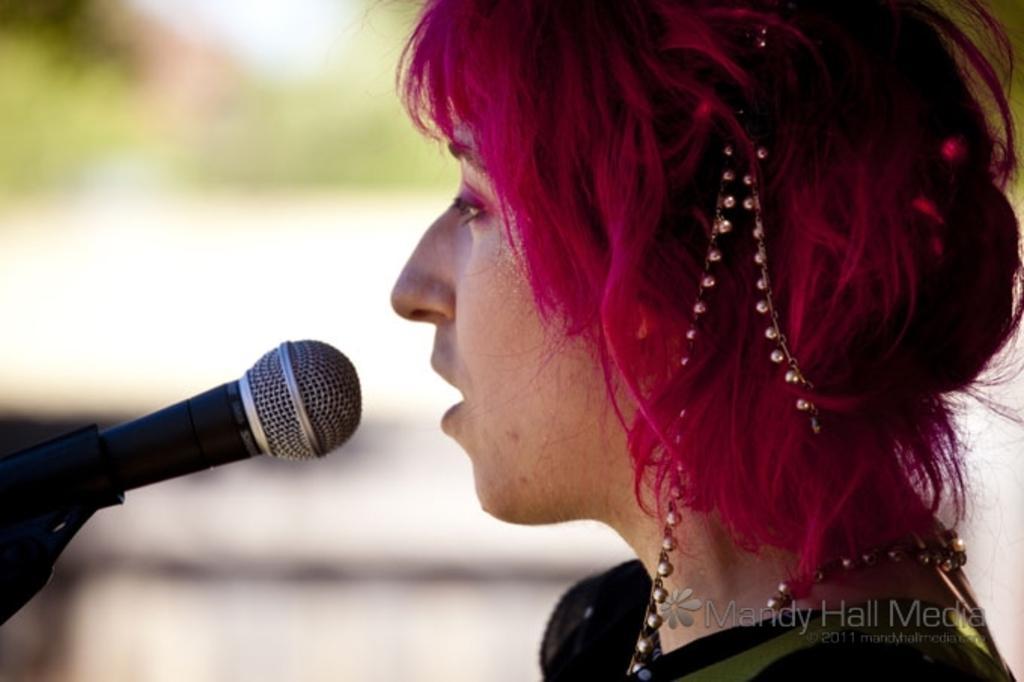In one or two sentences, can you explain what this image depicts? In the image we can see there is a woman and there is a mic kept on the stand. There is a beads chain on her hair and neck. Background of the image is blurred. 